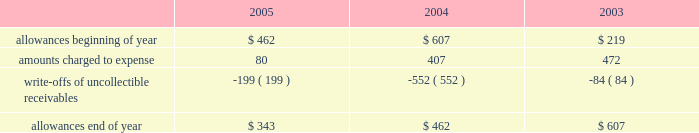Goodwill is reviewed annually during the fourth quarter for impairment .
In addition , the company performs an impairment analysis of other intangible assets based on the occurrence of other factors .
Such factors include , but are not limited to , signifi- cant changes in membership , state funding , medical contracts and provider networks and contracts .
An impairment loss is rec- ognized if the carrying value of intangible assets exceeds the implied fair value .
The company did not recognize any impair- ment losses for the periods presented .
Medical claims liabilities medical services costs include claims paid , claims reported but not yet paid ( inventory ) , estimates for claims incurred but not yet received ( ibnr ) and estimates for the costs necessary to process unpaid claims .
The estimates of medical claims liabilities are developed using standard actuarial methods based upon historical data for payment patterns , cost trends , product mix , seasonality , utiliza- tion of healthcare services and other relevant factors including product changes .
These estimates are continually reviewed and adjustments , if necessary , are reflected in the period known .
Management did not change actuarial methods during the years presented .
Management believes the amount of medical claims payable is reasonable and adequate to cover the company 2019s liabil- ity for unpaid claims as of december 31 , 2005 ; however , actual claim payments may differ from established estimates .
Revenue recognition the majority of the company 2019s medicaid managed care premi- um revenue is received monthly based on fixed rates per member as determined by state contracts .
Some contracts allow for addi- tional premium related to certain supplemental services provided such as maternity deliveries .
Revenue is recognized as earned over the covered period of services .
Revenues are recorded based on membership and eligibility data provided by the states , which may be adjusted by the states for updates to this membership and eligibility data .
These adjustments are immaterial in relation to total revenue recorded and are reflected in the period known .
Premiums collected in advance are recorded as unearned revenue .
The specialty services segment generates revenue under con- tracts with state and local government entities , our health plans and third-party customers .
Revenues for services are recognized when the services are provided or as ratably earned over the cov- ered period of services .
For performance-based contracts , the company does not recognize revenue subject to refund until data is sufficient to measure performance .
Such amounts are recorded as unearned revenue .
Revenues due to the company are recorded as premium and related receivables and recorded net of an allowance for uncol- lectible accounts based on historical trends and management 2019s judgment on the collectibility of these accounts .
Activity in the allowance for uncollectible accounts for the years ended december 31 is summarized below: .
Significant customers centene receives the majority of its revenues under contracts or subcontracts with state medicaid managed care programs .
The contracts , which expire on various dates between june 30 , 2006 and august 31 , 2008 , are expected to be renewed .
Contracts with the states of indiana , kansas , texas and wisconsin each accounted for 18% ( 18 % ) , 12% ( 12 % ) , 22% ( 22 % ) and 23% ( 23 % ) , respectively , of the company 2019s revenues for the year ended december 31 , 2005 .
Reinsurance centene has purchased reinsurance from third parties to cover eligible healthcare services .
The current reinsurance program covers 90% ( 90 % ) of inpatient healthcare expenses in excess of annual deductibles of $ 300 per member , up to a lifetime maximum of $ 2000 .
Centene 2019s medicaid managed care subsidiaries are respon- sible for inpatient charges in excess of an average daily per diem .
Reinsurance recoveries were $ 4014 , $ 3730 , and $ 5345 , in 2005 , 2004 , and 2003 , respectively .
Reinsurance expenses were approximately $ 4105 , $ 6724 , and $ 6185 in 2005 , 2004 , and 2003 , respectively .
Reinsurance recoveries , net of expenses , are included in medical costs .
Other income ( expense ) other income ( expense ) consists principally of investment income and interest expense .
Investment income is derived from the company 2019s cash , cash equivalents , restricted deposits and investments .
Interest expense relates to borrowings under our credit facility , mortgage interest , interest on capital leases and credit facility fees .
Income taxes deferred tax assets and liabilities are recorded for the future tax consequences attributable to differences between the financial statement carrying amounts of existing assets and liabilities and their respective tax bases .
Deferred tax assets and liabilities are measured using enacted tax rates expected to apply to taxable income in the years in which those temporary differences are expected to be recovered or settled .
The effect on deferred tax assets and liabilities of a change in tax rates is recognized in income in the period that includes the enactment date of the tax rate change .
Valuation allowances are provided when it is considered more likely than not that deferred tax assets will not be realized .
In determining if a deductible temporary difference or net operating loss can be realized , the company considers future reversals of .
What was the percentage change in the allowance for uncollectible accounts from year end 2003 to 2004? 
Computations: ((462 - 607) / 607)
Answer: -0.23888. 